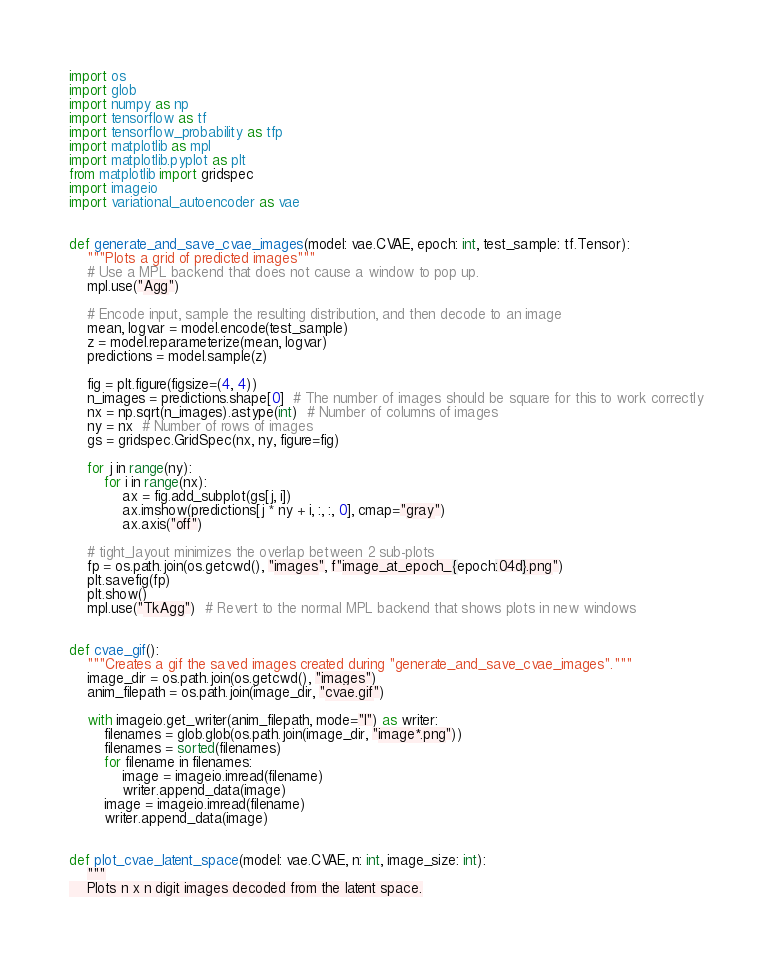<code> <loc_0><loc_0><loc_500><loc_500><_Python_>import os
import glob
import numpy as np
import tensorflow as tf
import tensorflow_probability as tfp
import matplotlib as mpl
import matplotlib.pyplot as plt
from matplotlib import gridspec
import imageio
import variational_autoencoder as vae


def generate_and_save_cvae_images(model: vae.CVAE, epoch: int, test_sample: tf.Tensor):
    """Plots a grid of predicted images"""
    # Use a MPL backend that does not cause a window to pop up.
    mpl.use("Agg")

    # Encode input, sample the resulting distribution, and then decode to an image
    mean, logvar = model.encode(test_sample)
    z = model.reparameterize(mean, logvar)
    predictions = model.sample(z)

    fig = plt.figure(figsize=(4, 4))
    n_images = predictions.shape[0]  # The number of images should be square for this to work correctly
    nx = np.sqrt(n_images).astype(int)  # Number of columns of images
    ny = nx  # Number of rows of images
    gs = gridspec.GridSpec(nx, ny, figure=fig)

    for j in range(ny):
        for i in range(nx):
            ax = fig.add_subplot(gs[j, i])
            ax.imshow(predictions[j * ny + i, :, :, 0], cmap="gray")
            ax.axis("off")

    # tight_layout minimizes the overlap between 2 sub-plots
    fp = os.path.join(os.getcwd(), "images", f"image_at_epoch_{epoch:04d}.png")
    plt.savefig(fp)
    plt.show()
    mpl.use("TkAgg")  # Revert to the normal MPL backend that shows plots in new windows


def cvae_gif():
    """Creates a gif the saved images created during "generate_and_save_cvae_images"."""
    image_dir = os.path.join(os.getcwd(), "images")
    anim_filepath = os.path.join(image_dir, "cvae.gif")

    with imageio.get_writer(anim_filepath, mode="I") as writer:
        filenames = glob.glob(os.path.join(image_dir, "image*.png"))
        filenames = sorted(filenames)
        for filename in filenames:
            image = imageio.imread(filename)
            writer.append_data(image)
        image = imageio.imread(filename)
        writer.append_data(image)


def plot_cvae_latent_space(model: vae.CVAE, n: int, image_size: int):
    """
    Plots n x n digit images decoded from the latent space.</code> 